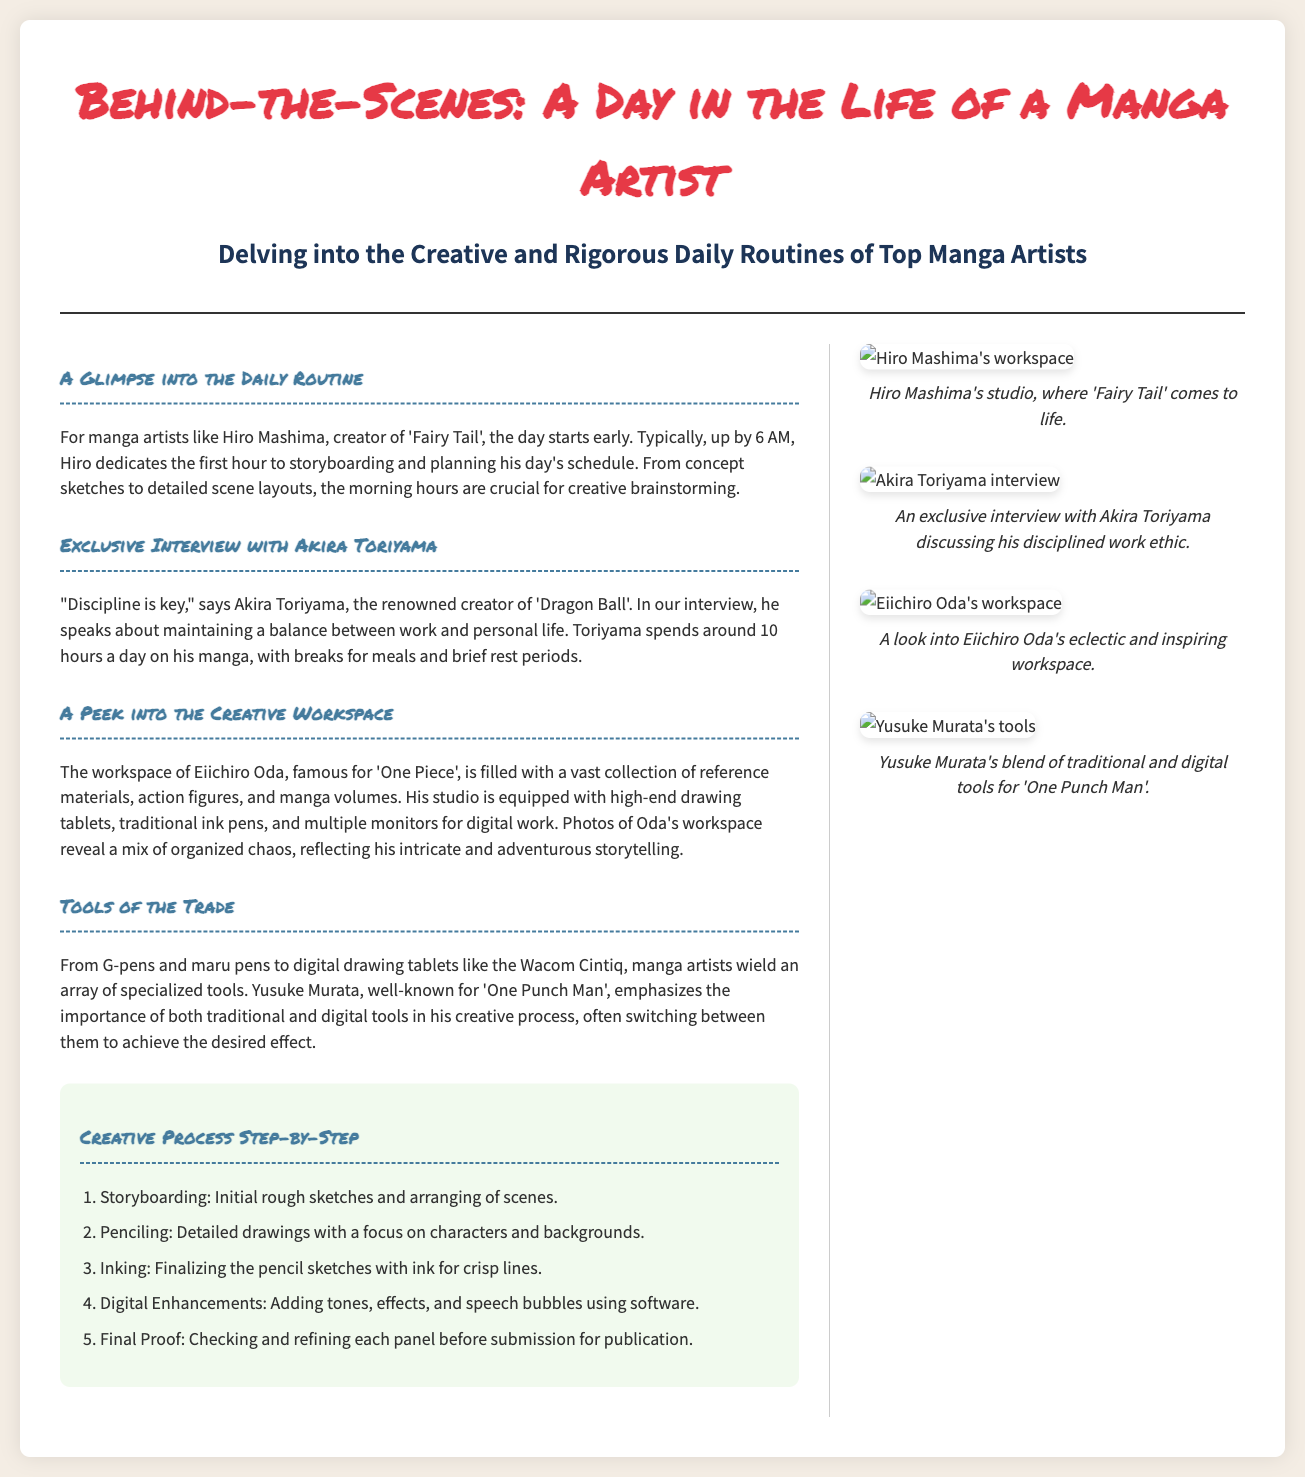What time does Hiro Mashima typically wake up? The document states that Hiro Mashima starts his day early, typically up by 6 AM.
Answer: 6 AM How many hours a day does Akira Toriyama spend on his manga? According to the interview, Akira Toriyama spends around 10 hours a day on his manga.
Answer: 10 hours What is emphasized by Yusuke Murata regarding his tools? The document mentions that Yusuke Murata emphasizes the importance of both traditional and digital tools in his creative process.
Answer: Importance of both What is the first step in the creative process? The document outlines that the first step in the creative process is storyboarding.
Answer: Storyboarding What type of tablet does Eiichiro Oda use? It is mentioned that Eiichiro Oda's studio is equipped with high-end drawing tablets, including the Wacom Cintiq.
Answer: Wacom Cintiq What genre is Hiro Mashima known for? The document refers to Hiro Mashima as the creator of 'Fairy Tail', which is a fantasy adventure manga.
Answer: Fantasy adventure How is Eiichiro Oda's workspace described? The document describes Eiichiro Oda's workspace as filled with a vast collection of reference materials, action figures, and manga volumes.
Answer: Organized chaos Which artist is featured in the exclusive interview section? The document specifies that the exclusive interview features Akira Toriyama.
Answer: Akira Toriyama 